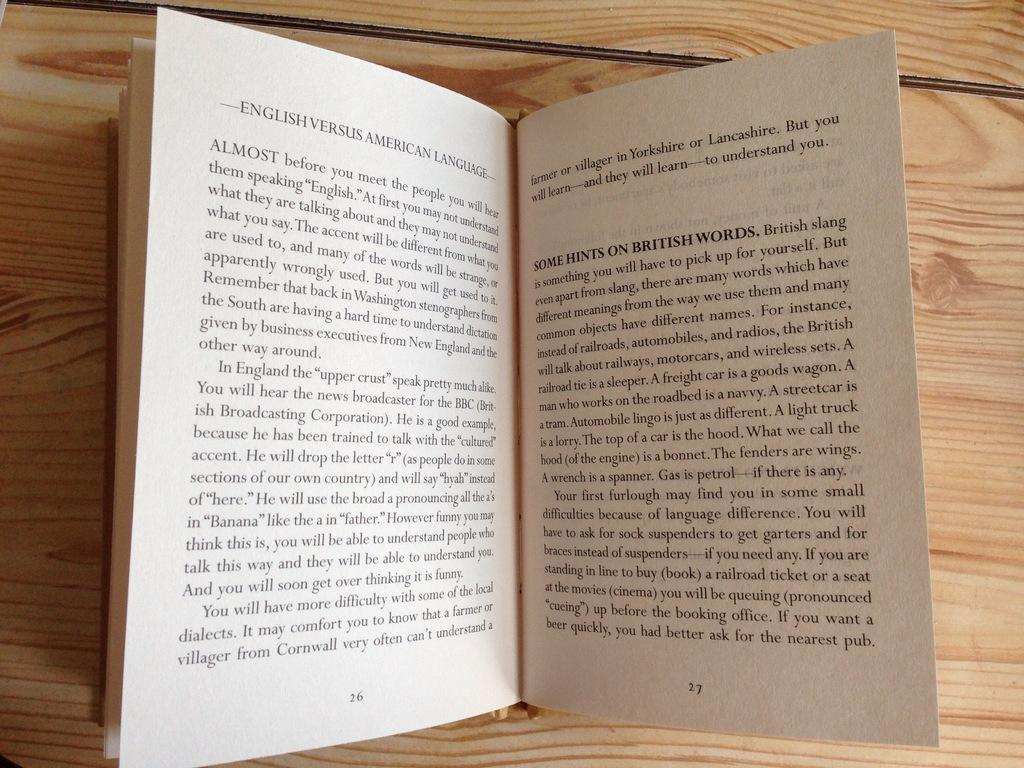On the page on the right, what types of words are hints given for?
Ensure brevity in your answer.  British. What is the first word on the left page?
Offer a very short reply. English. 